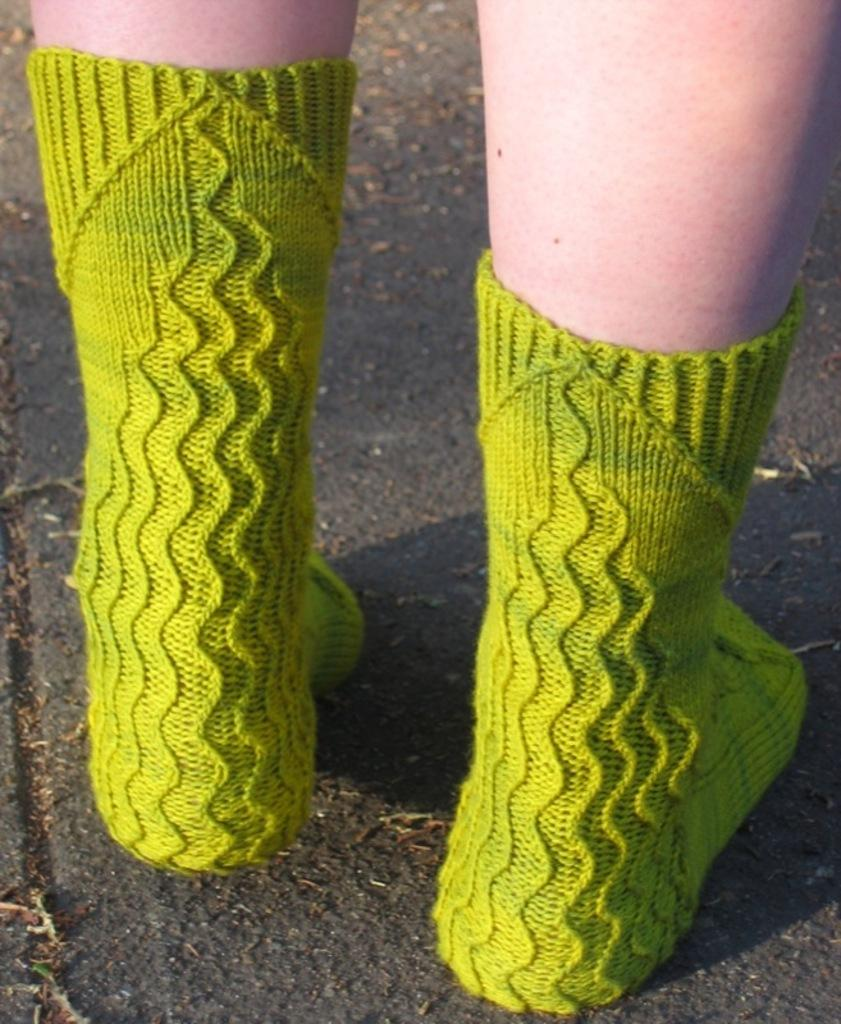Who or what is present in the image? There is a person in the image. What are the person's socks like? The person is wearing green socks. What can be seen at the bottom of the image? There is a road visible at the bottom of the image. What type of loaf is being used to pave the road in the image? There is no loaf present in the image, and the road is not being paved with any type of loaf. 